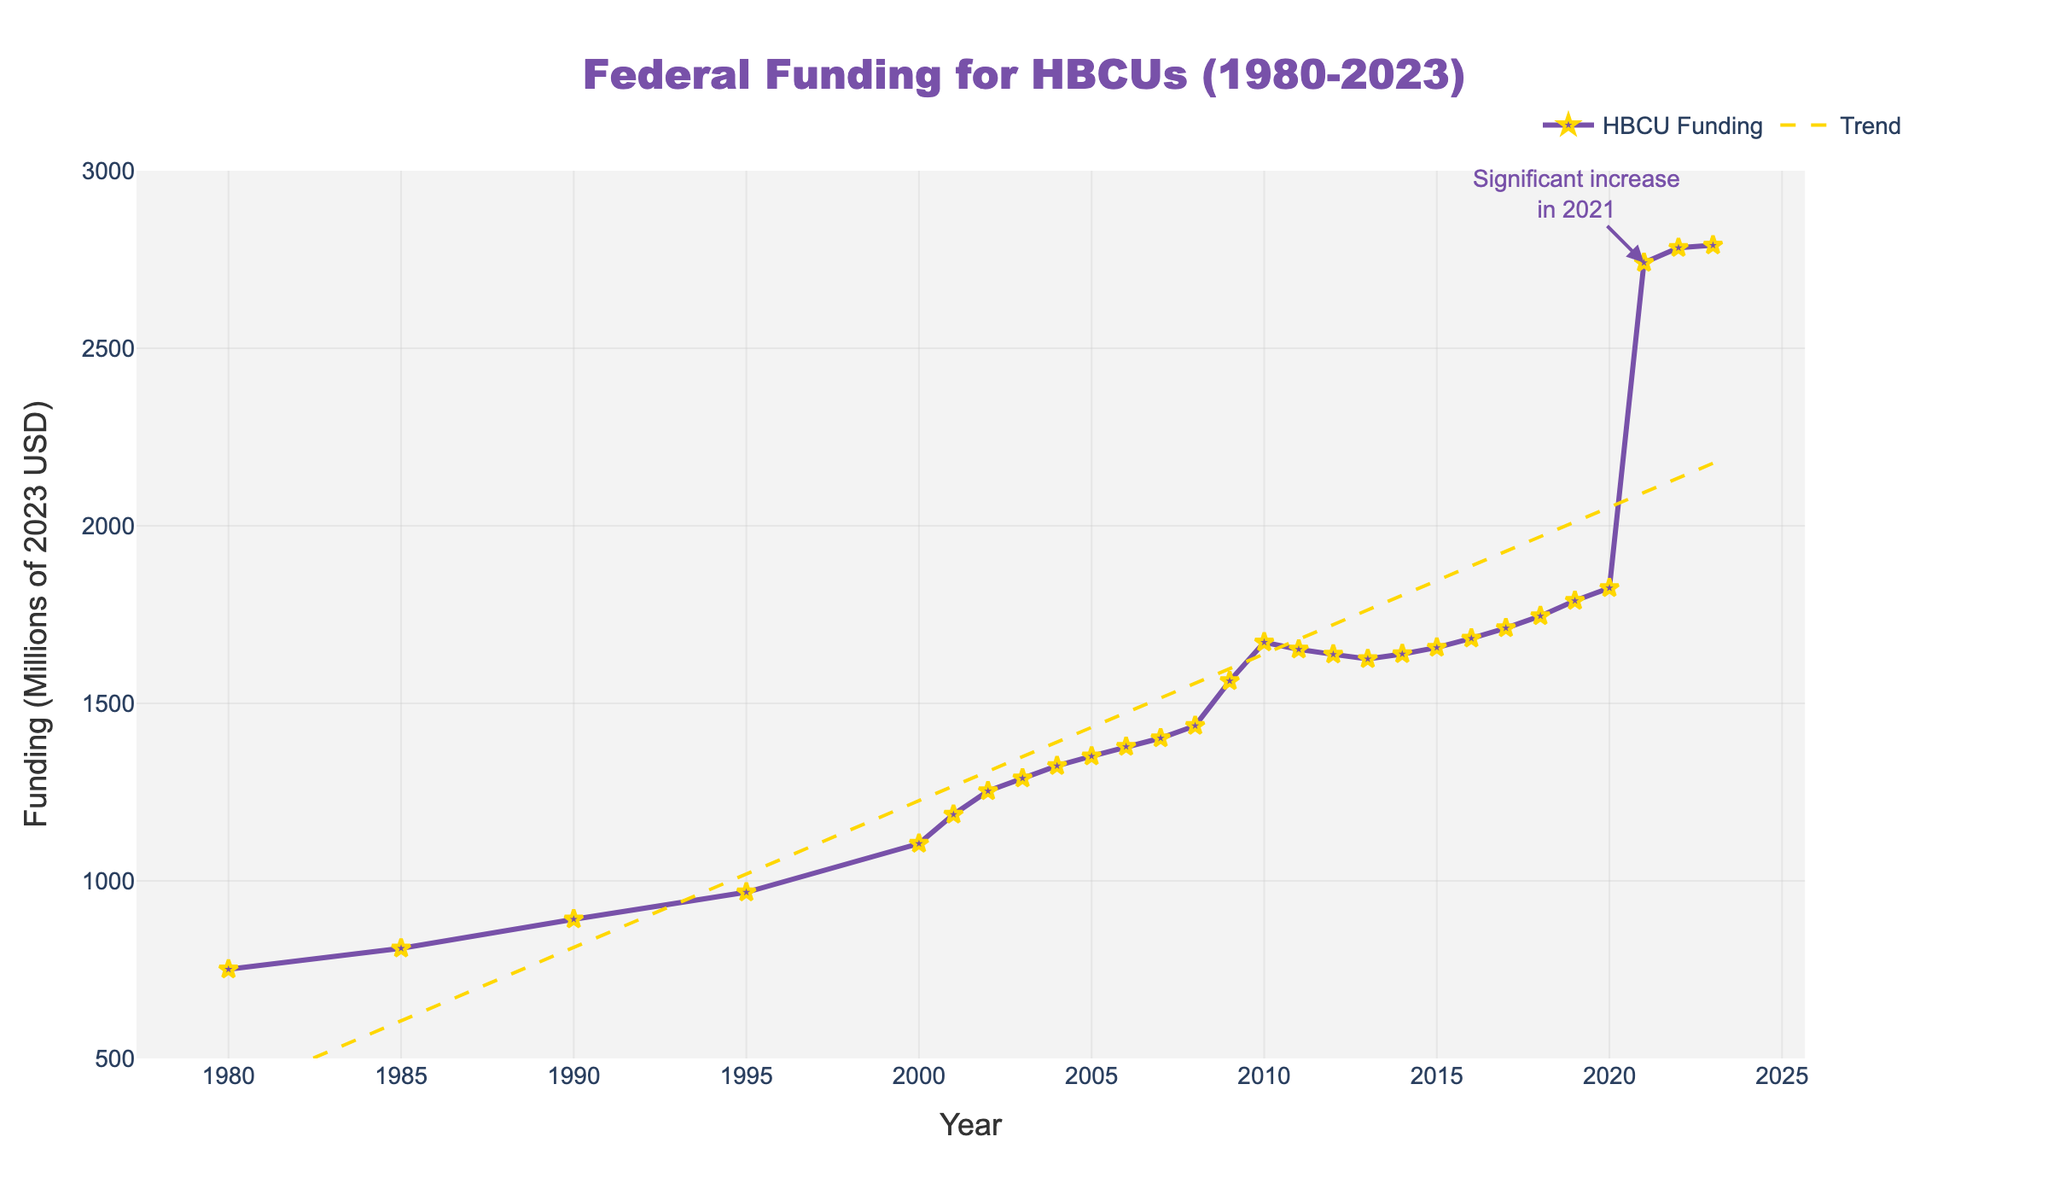What year saw the highest federal funding for HBCUs? By looking at the chart, the peak point in the line for federal funding occurs in 2023. This is indicated by the star marker at its highest point on the y-axis that reaches nearly 2800 million USD.
Answer: 2023 How does the federal funding in 1980 compare to the funding in 2020? To compare the funding amounts, locate the y-values at the years 1980 and 2020. In 1980, the funding was 751 million USD, and in 2020, it was 1825 million USD. This shows a significant increase over time.
Answer: Funding in 2020 is higher than in 1980 What is the trend in the federal funding allocation between 2019 and 2021? By examining the line for federal funding between the years 2019 and 2021, it's clear that there is a noticeable increase, with a significant jump occurring around 2021. This is also highlighted by the annotation on the chart.
Answer: Increasing trend with a significant jump Calculate the average funding for the years from 1980 to 1985. From the data, the funding in 1980 is 751 million USD, and in 1985 it is 810 million USD. Average funding = (751 + 810) / 2 = 1561 / 2 = 780.5 million USD.
Answer: 780.5 million USD What decade experienced the most growth in federal funding? By examining the chart and comparing the funding at the start and end of each decade, the decade with the highest increase can be identified. The steepest slope appears between 2010 and 2020, where the funding increases significantly.
Answer: 2010-2020 What's the difference in federal funding between 2008 and 2009? By observing the chart, locate the funding values for the years 2008 and 2009. The values are 1437 million USD for 2008 and 1563 million USD for 2009. Calculate the difference: 1563 - 1437 = 126 million USD.
Answer: 126 million USD Which year shows a trendline value closest to the actual funding value? By closely comparing the trendline and the actual funding line, it seems that in 2020, the actual funding value and the trendline value are nearly identical.
Answer: 2020 Is there any year where the funding decreased from the previous year? By examining the chart for any downward slopes or dips, observe the transition between 2010 and 2011, where the funding decreases from 1672 million USD to 1652 million USD.
Answer: 2011 What visual feature highlights the significant increase in 2021? The significant increase in 2021 is emphasized by an annotation on the chart pointing to the large jump in funding, along with the peak value represented by a star marker.
Answer: Annotation and star marker 